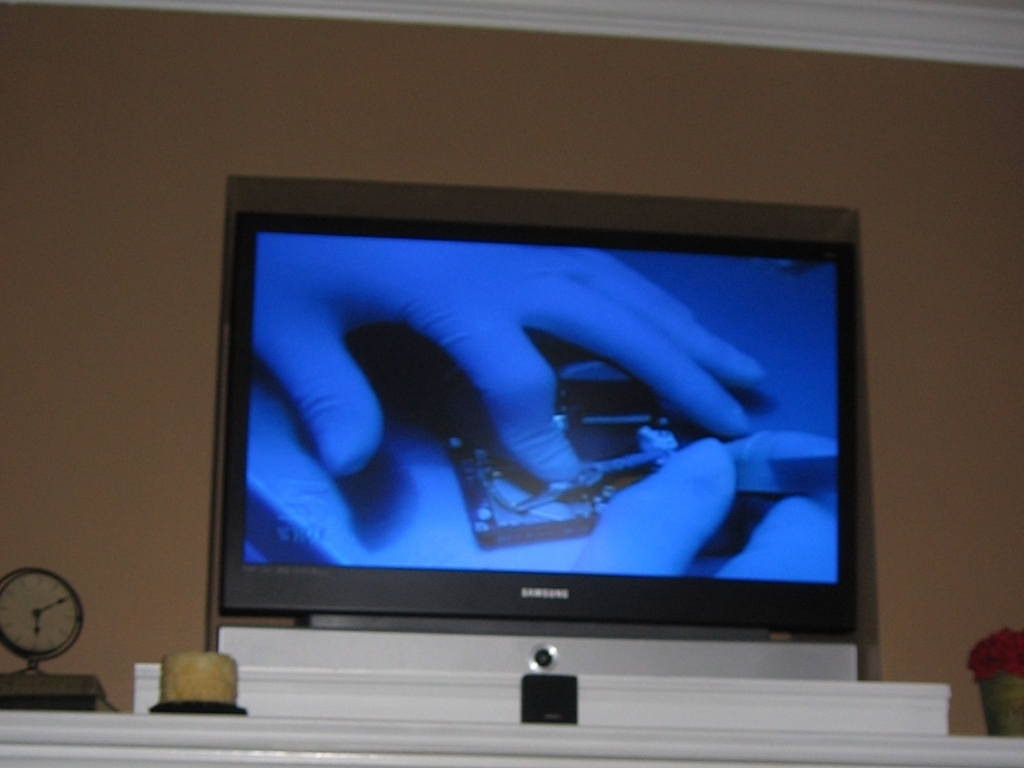Could you speculate on what time of day the photo was taken? Given the ambient lighting in the room and the absence of sunlight or shadows, it's likely that the photo was taken in the evening, or in a room without natural light during the day. The warm hue of the walls also suggests indoor lighting is in use. 